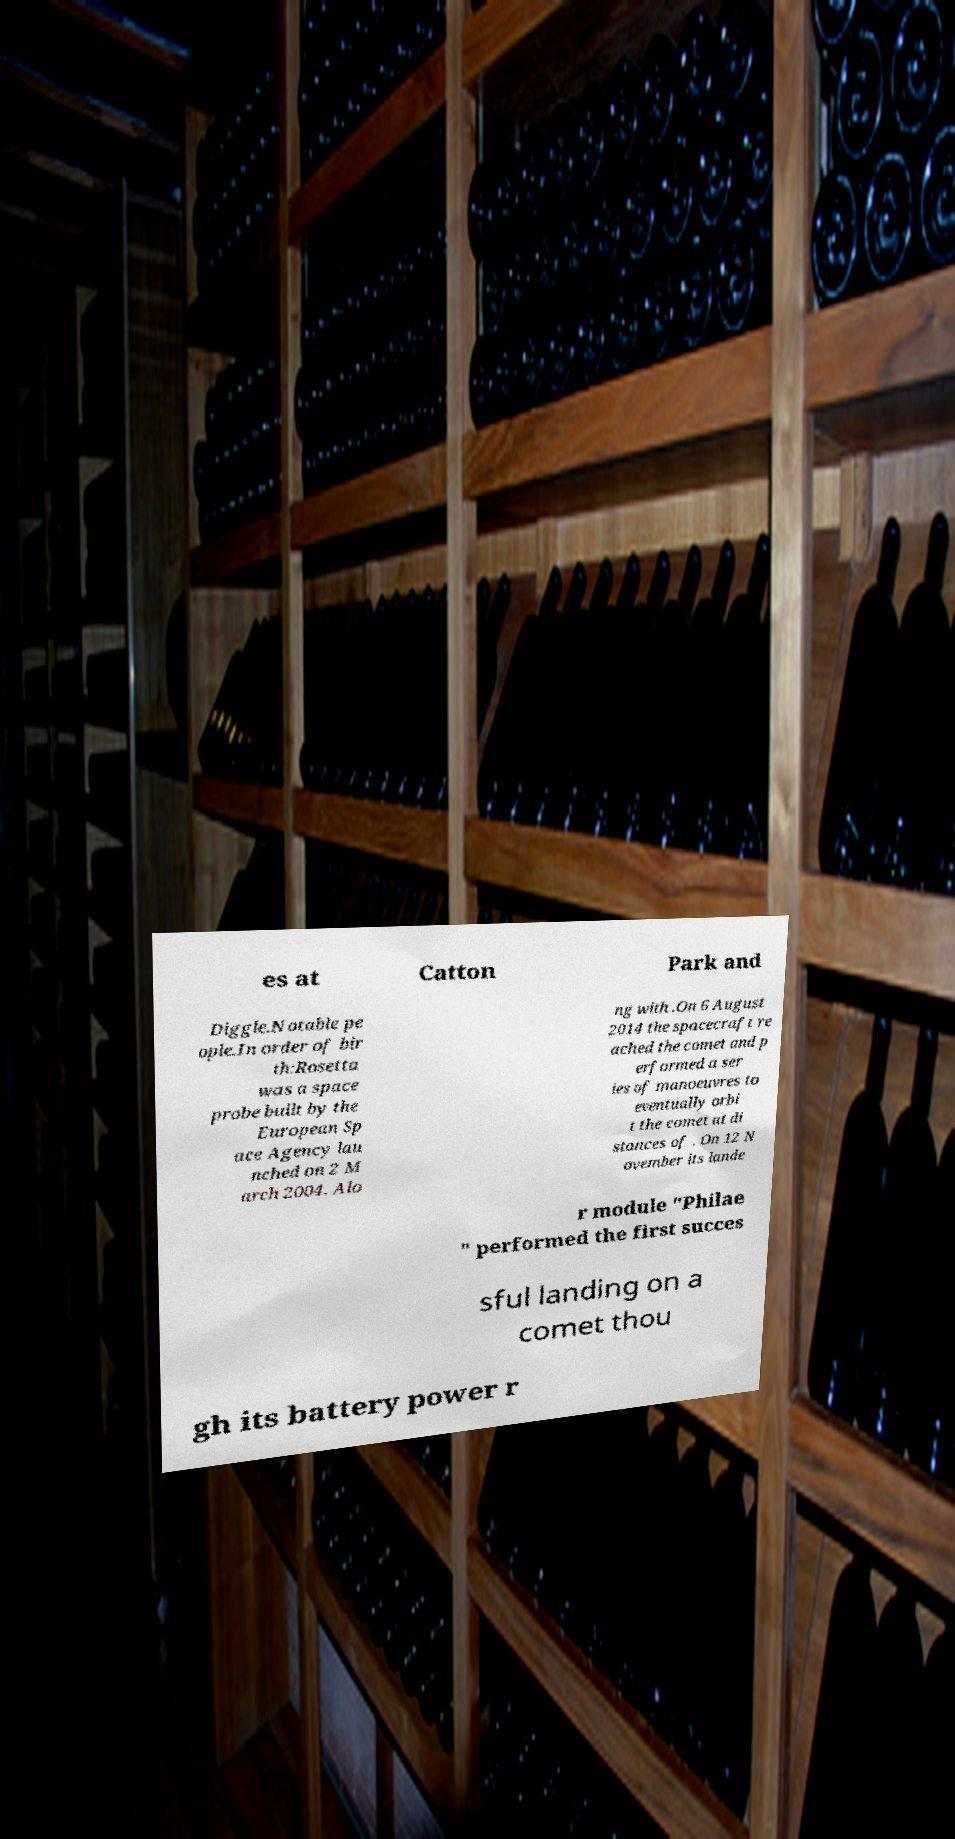What messages or text are displayed in this image? I need them in a readable, typed format. es at Catton Park and Diggle.Notable pe ople.In order of bir th:Rosetta was a space probe built by the European Sp ace Agency lau nched on 2 M arch 2004. Alo ng with .On 6 August 2014 the spacecraft re ached the comet and p erformed a ser ies of manoeuvres to eventually orbi t the comet at di stances of . On 12 N ovember its lande r module "Philae " performed the first succes sful landing on a comet thou gh its battery power r 